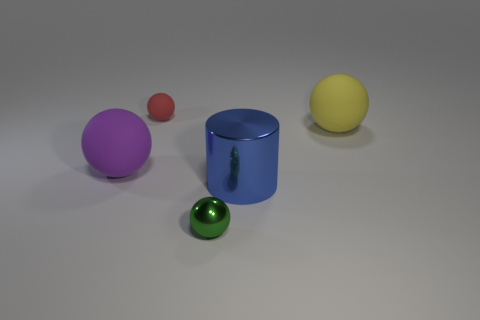The blue shiny thing has what size?
Ensure brevity in your answer.  Large. Is the size of the ball that is to the right of the tiny metal ball the same as the ball that is in front of the large purple ball?
Provide a short and direct response. No. What size is the green shiny thing that is the same shape as the purple rubber object?
Offer a terse response. Small. Does the purple rubber sphere have the same size as the matte thing to the right of the small green thing?
Give a very brief answer. Yes. There is a rubber ball that is on the right side of the blue cylinder; is there a red thing on the right side of it?
Offer a terse response. No. There is a matte thing that is to the right of the green metallic object; what shape is it?
Offer a terse response. Sphere. What color is the large matte sphere to the left of the tiny ball behind the yellow matte ball?
Your response must be concise. Purple. Do the shiny ball and the purple sphere have the same size?
Make the answer very short. No. There is a green object that is the same shape as the small red thing; what material is it?
Your response must be concise. Metal. What number of blue metallic objects have the same size as the purple matte ball?
Keep it short and to the point. 1. 